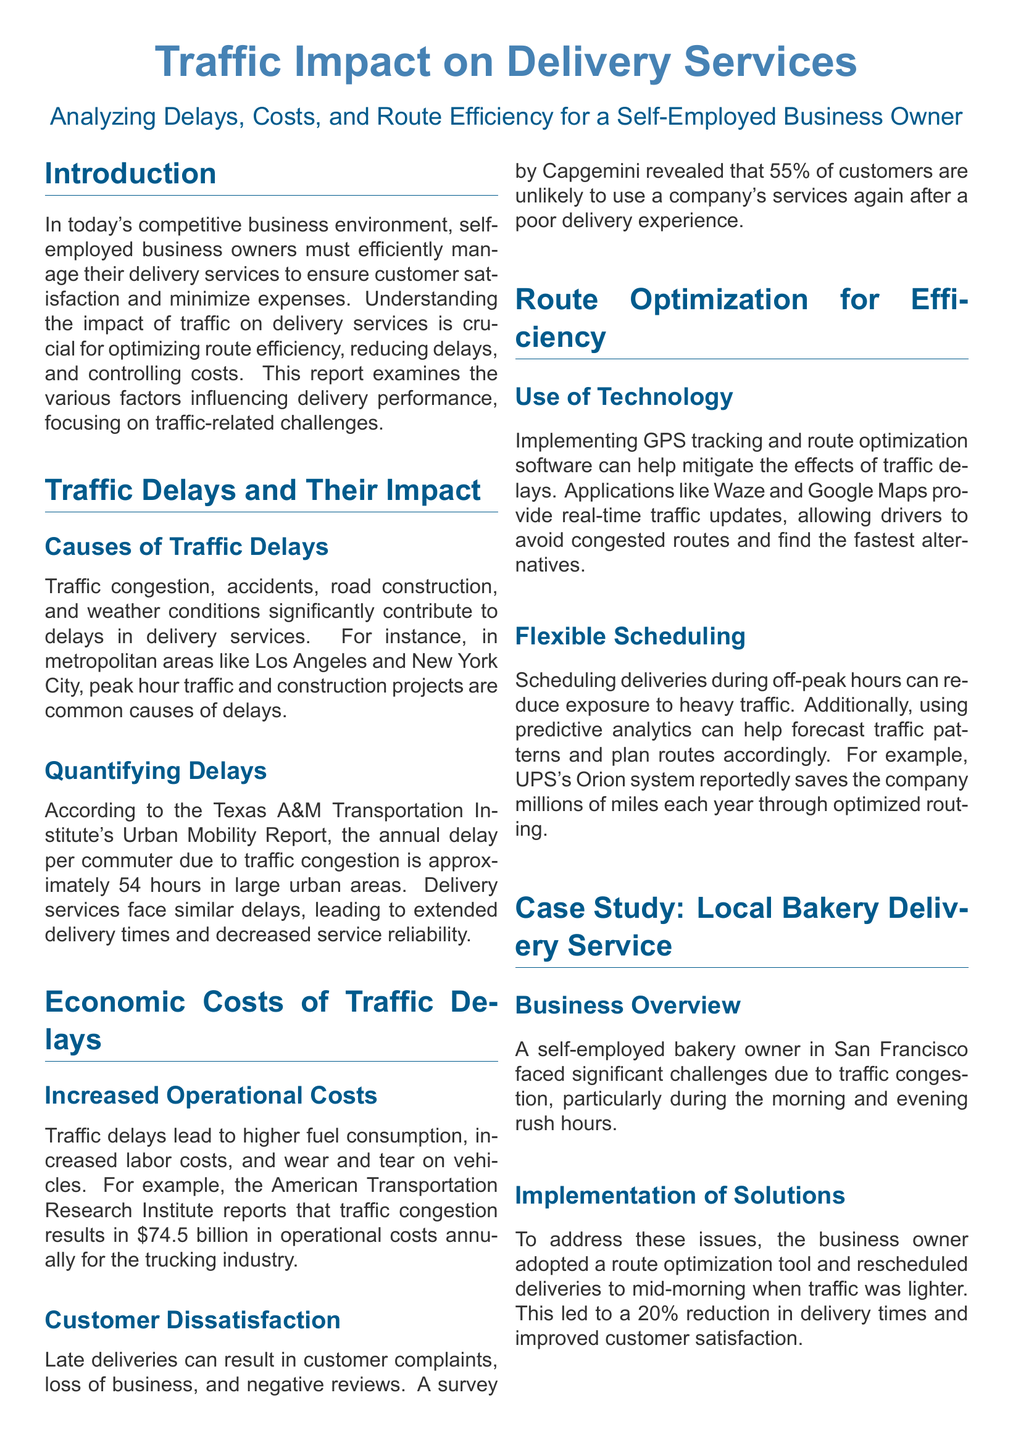what is the annual delay per commuter in large urban areas? The document states that the annual delay per commuter due to traffic congestion is approximately 54 hours.
Answer: 54 hours what is one cause of traffic delays mentioned in the report? The report lists traffic congestion, accidents, road construction, and weather conditions as significant causes of delays.
Answer: traffic congestion what percentage of customers are unlikely to use a company's services again after a poor delivery experience? The survey by Capgemini revealed that 55% of customers are unlikely to use a company's services again after a poor delivery experience.
Answer: 55% which technology is suggested for route optimization? The document mentions GPS tracking and route optimization software as technologies that can help mitigate the effects of traffic delays.
Answer: GPS tracking and route optimization software by what percentage did the bakery owner reduce delivery times after implementing solutions? The case study specifies that the bakery owner achieved a 20% reduction in delivery times after implementing a route optimization tool.
Answer: 20% what is one economic cost of traffic delays according to the American Transportation Research Institute? The American Transportation Research Institute reports that traffic congestion results in $74.5 billion in operational costs annually for the trucking industry.
Answer: $74.5 billion when did the bakery owner in San Francisco schedule deliveries to avoid traffic congestion? The bakery owner rescheduled deliveries to mid-morning when traffic was lighter.
Answer: mid-morning what is one benefit of using predictive analytics mentioned in the report? The document states that using predictive analytics can help forecast traffic patterns and plan routes accordingly.
Answer: forecast traffic patterns what city did the case study focus on for the local bakery delivery service? The case study focused on a local bakery delivery service in San Francisco.
Answer: San Francisco 